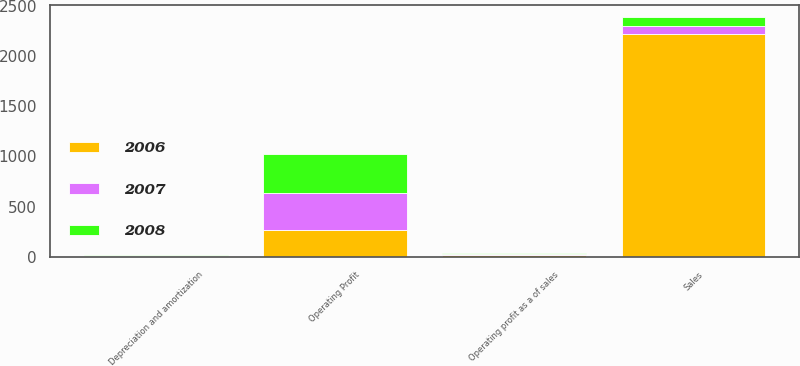<chart> <loc_0><loc_0><loc_500><loc_500><stacked_bar_chart><ecel><fcel>Sales<fcel>Operating Profit<fcel>Depreciation and amortization<fcel>Operating profit as a of sales<nl><fcel>2007<fcel>84.3<fcel>370.5<fcel>3.8<fcel>11.3<nl><fcel>2008<fcel>84.3<fcel>393.2<fcel>4<fcel>13.1<nl><fcel>2006<fcel>2220<fcel>261.6<fcel>3.8<fcel>11.8<nl></chart> 